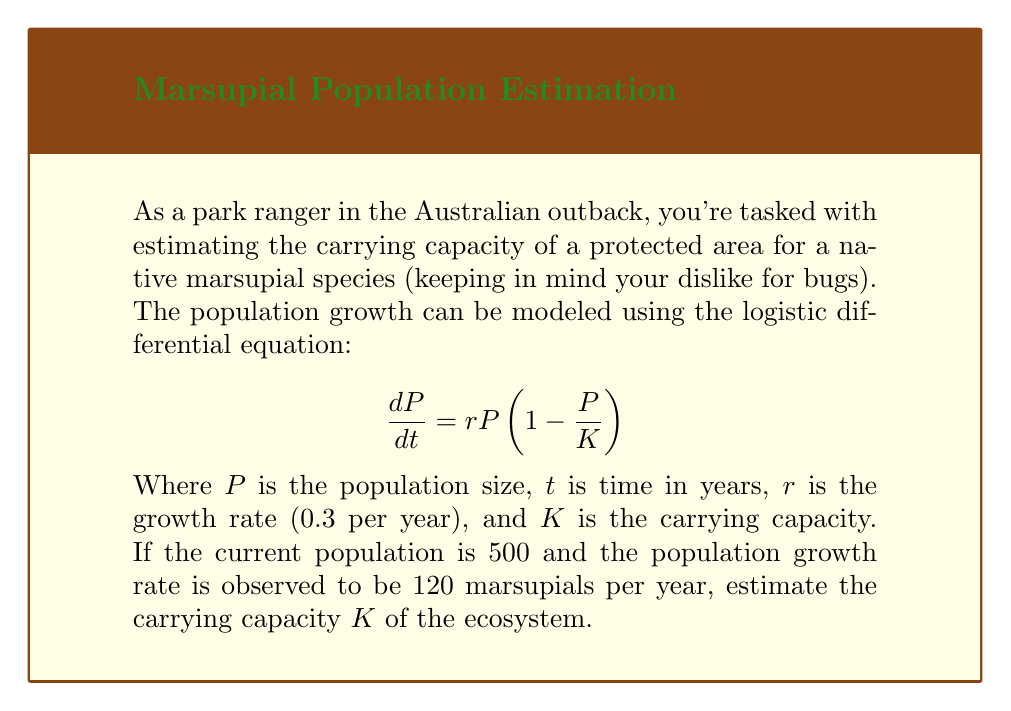Could you help me with this problem? Let's approach this step-by-step:

1) We are given the logistic growth equation:
   $$\frac{dP}{dt} = rP(1 - \frac{P}{K})$$

2) We know the following:
   - Current population, $P = 500$
   - Growth rate, $r = 0.3$ per year
   - Current population growth rate, $\frac{dP}{dt} = 120$ marsupials per year

3) Let's substitute these values into the equation:
   $$120 = 0.3 \cdot 500 \cdot (1 - \frac{500}{K})$$

4) Simplify:
   $$120 = 150 \cdot (1 - \frac{500}{K})$$

5) Divide both sides by 150:
   $$\frac{4}{5} = 1 - \frac{500}{K}$$

6) Subtract both sides from 1:
   $$\frac{1}{5} = \frac{500}{K}$$

7) Multiply both sides by $K$:
   $$\frac{K}{5} = 500$$

8) Multiply both sides by 5:
   $$K = 2500$$

Therefore, the estimated carrying capacity of the ecosystem is 2500 marsupials.
Answer: 2500 marsupials 